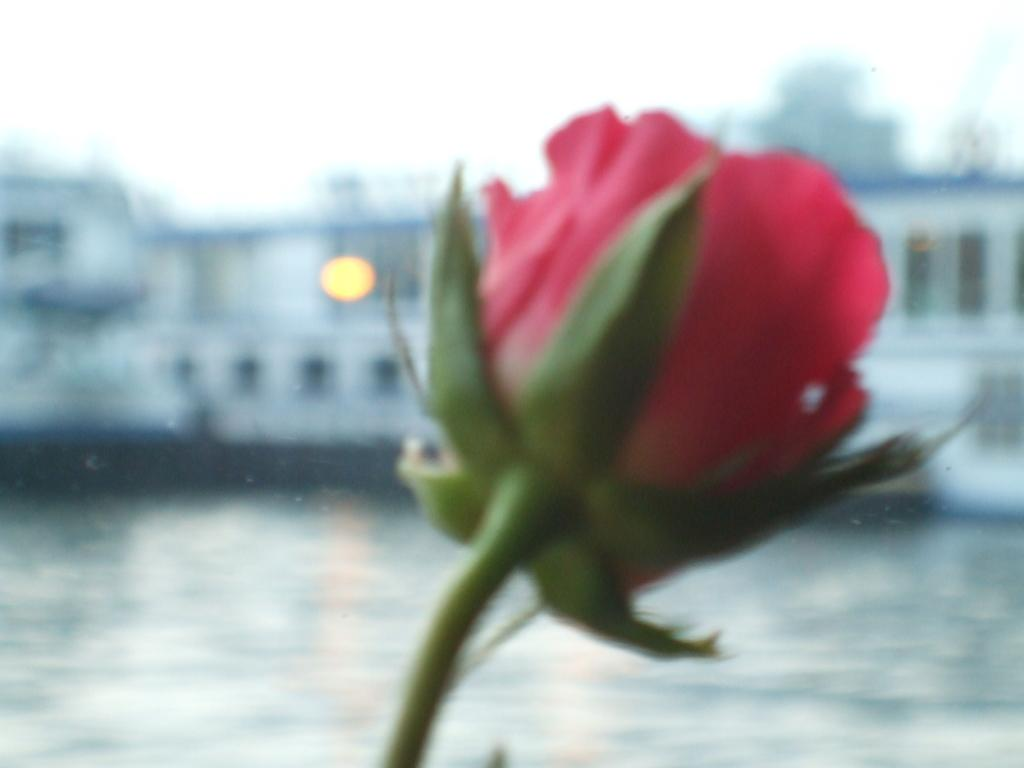What type of flower is in the image? There is a red color rose in the image. What can be seen in the background of the image? There is a white color building in the background of the image. How would you describe the clarity of the image? The image is blurry. How many toes are visible on the rose in the image? There are no toes present in the image, as it features a red color rose and a white color building in the background. 